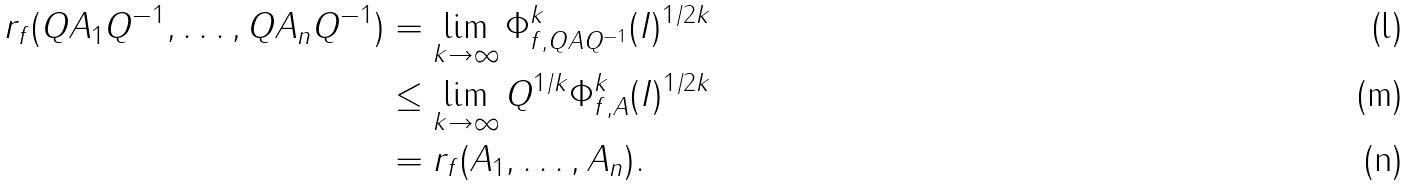Convert formula to latex. <formula><loc_0><loc_0><loc_500><loc_500>r _ { f } ( Q A _ { 1 } Q ^ { - 1 } , \dots , Q A _ { n } Q ^ { - 1 } ) & = \lim _ { k \to \infty } \| \Phi _ { f , Q A Q ^ { - 1 } } ^ { k } ( I ) \| ^ { 1 / 2 k } \\ & \leq \lim _ { k \to \infty } \| Q \| ^ { 1 / k } \| \Phi _ { f , A } ^ { k } ( I ) \| ^ { 1 / 2 k } \\ & = r _ { f } ( A _ { 1 } , \dots , A _ { n } ) .</formula> 